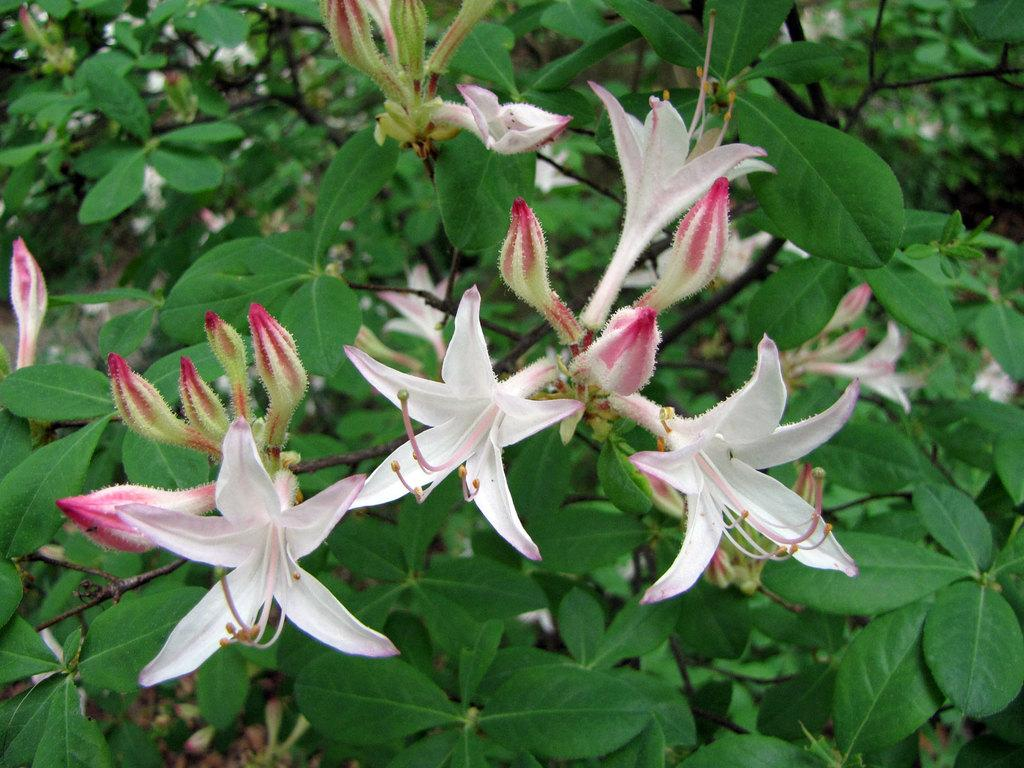Where was the picture taken? The picture was clicked outside. What is the main focus of the image? The main focus of the image is flowers and buds in the center. What type of vegetation can be seen in the image? There are green leaves of plants and plants visible in the image. What can be seen in the background of the image? There are plants visible in the background of the image. What type of insurance is being advertised in the image? There is no advertisement present in the image, and therefore no insurance being advertised. Can you touch the flowers in the image? The image is a two-dimensional representation, so you cannot physically touch the flowers in the image. 